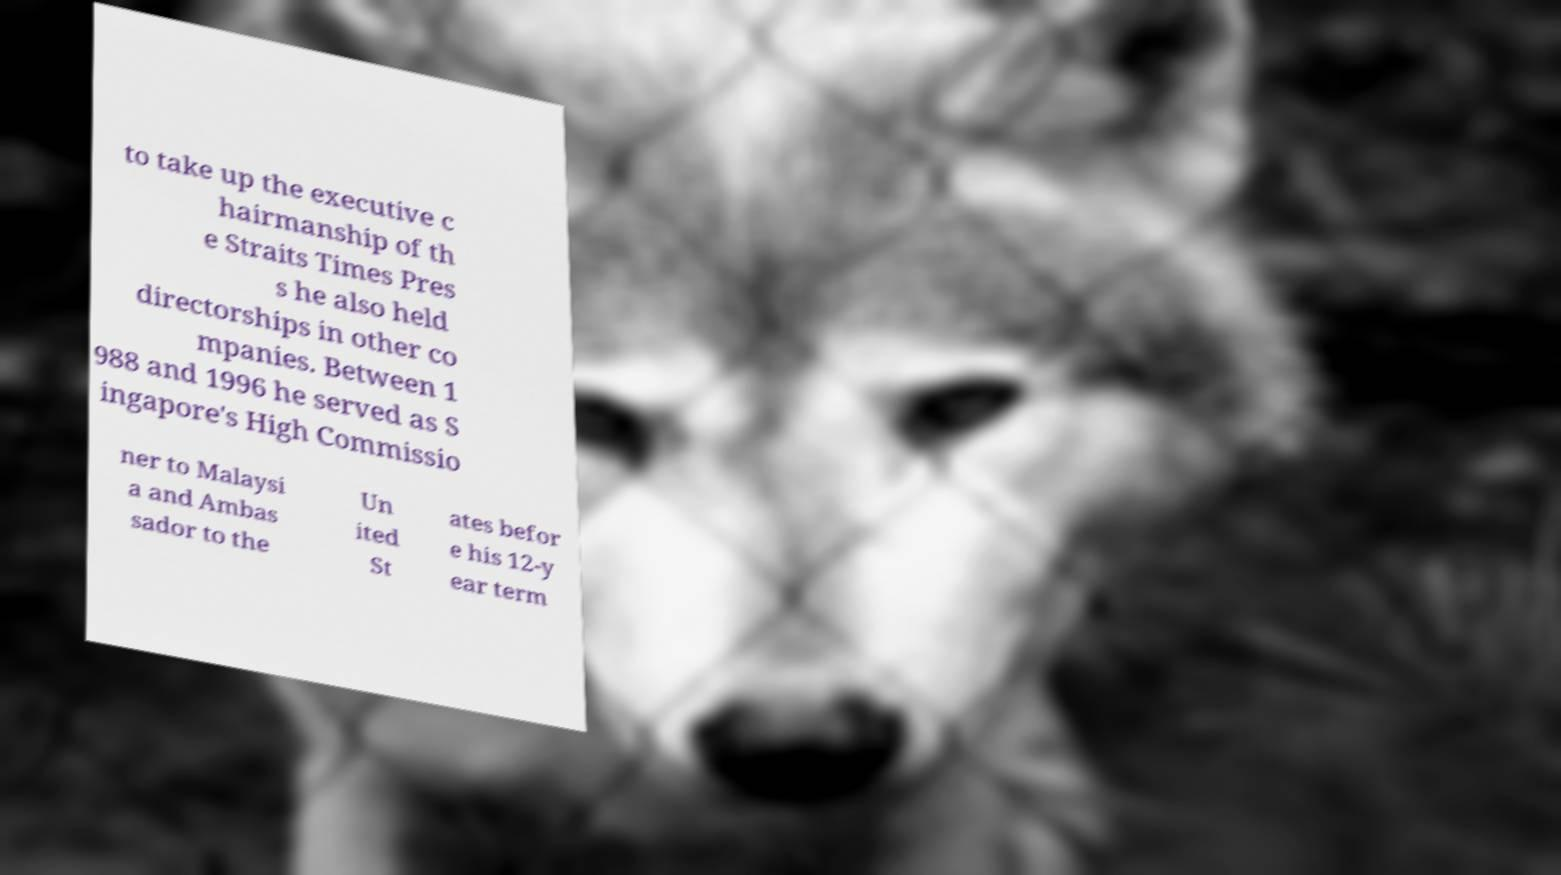Please read and relay the text visible in this image. What does it say? to take up the executive c hairmanship of th e Straits Times Pres s he also held directorships in other co mpanies. Between 1 988 and 1996 he served as S ingapore's High Commissio ner to Malaysi a and Ambas sador to the Un ited St ates befor e his 12-y ear term 